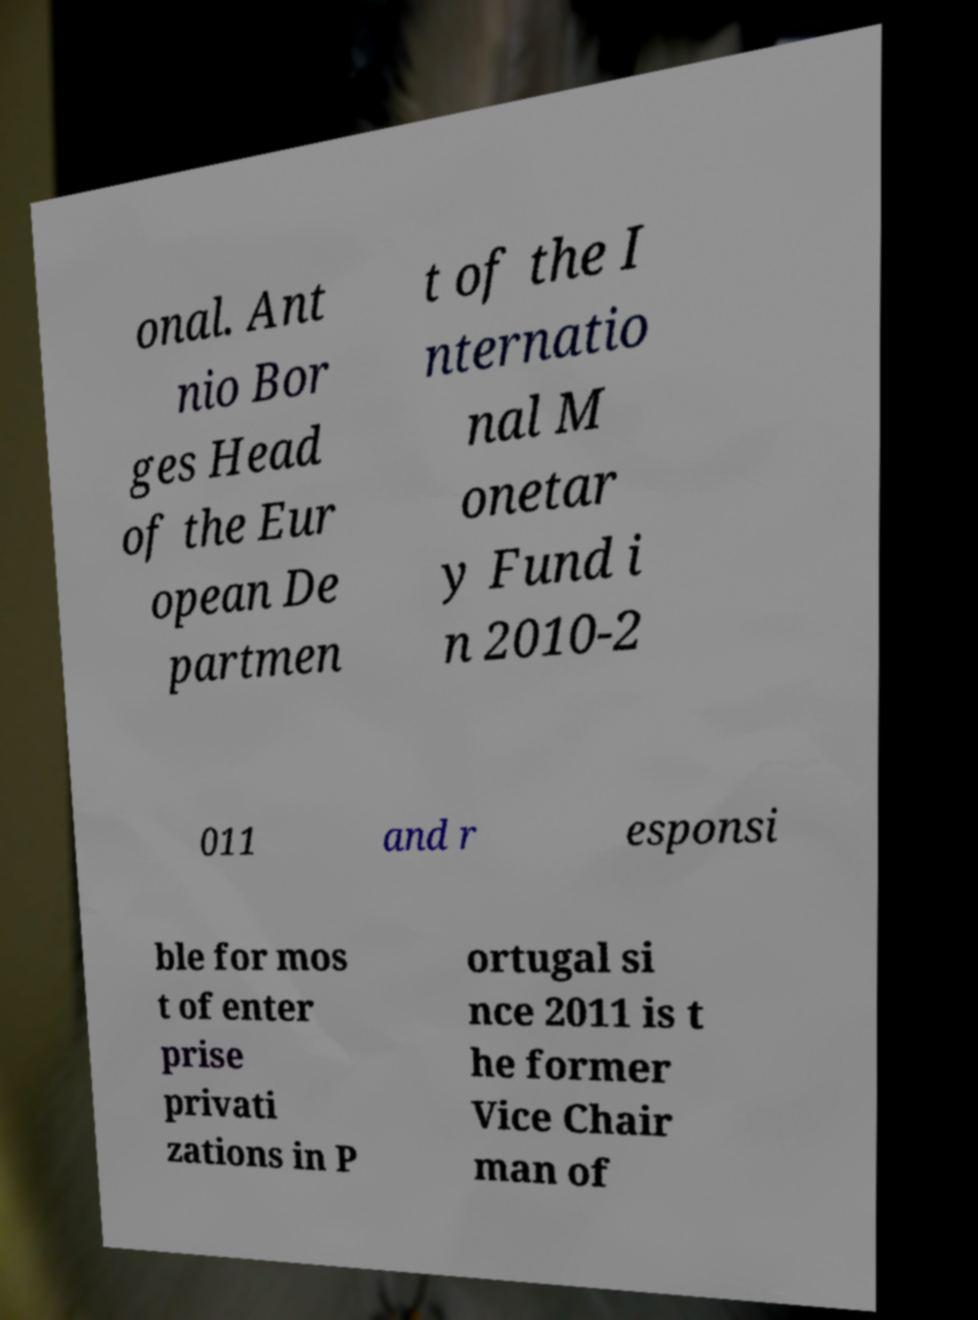Could you assist in decoding the text presented in this image and type it out clearly? onal. Ant nio Bor ges Head of the Eur opean De partmen t of the I nternatio nal M onetar y Fund i n 2010-2 011 and r esponsi ble for mos t of enter prise privati zations in P ortugal si nce 2011 is t he former Vice Chair man of 